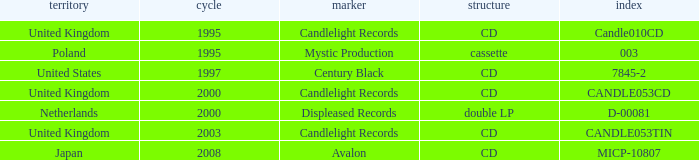What year did Japan form a label? 2008.0. 